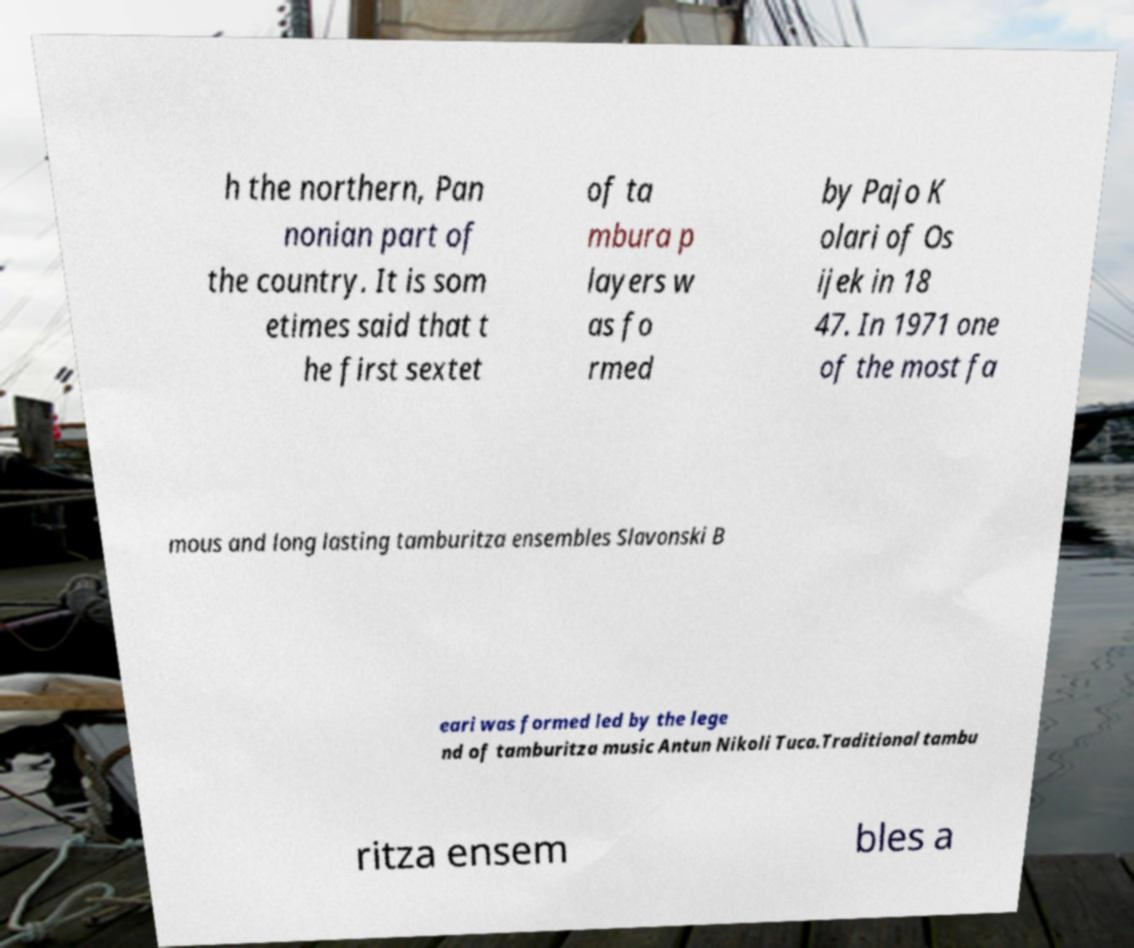For documentation purposes, I need the text within this image transcribed. Could you provide that? h the northern, Pan nonian part of the country. It is som etimes said that t he first sextet of ta mbura p layers w as fo rmed by Pajo K olari of Os ijek in 18 47. In 1971 one of the most fa mous and long lasting tamburitza ensembles Slavonski B eari was formed led by the lege nd of tamburitza music Antun Nikoli Tuca.Traditional tambu ritza ensem bles a 